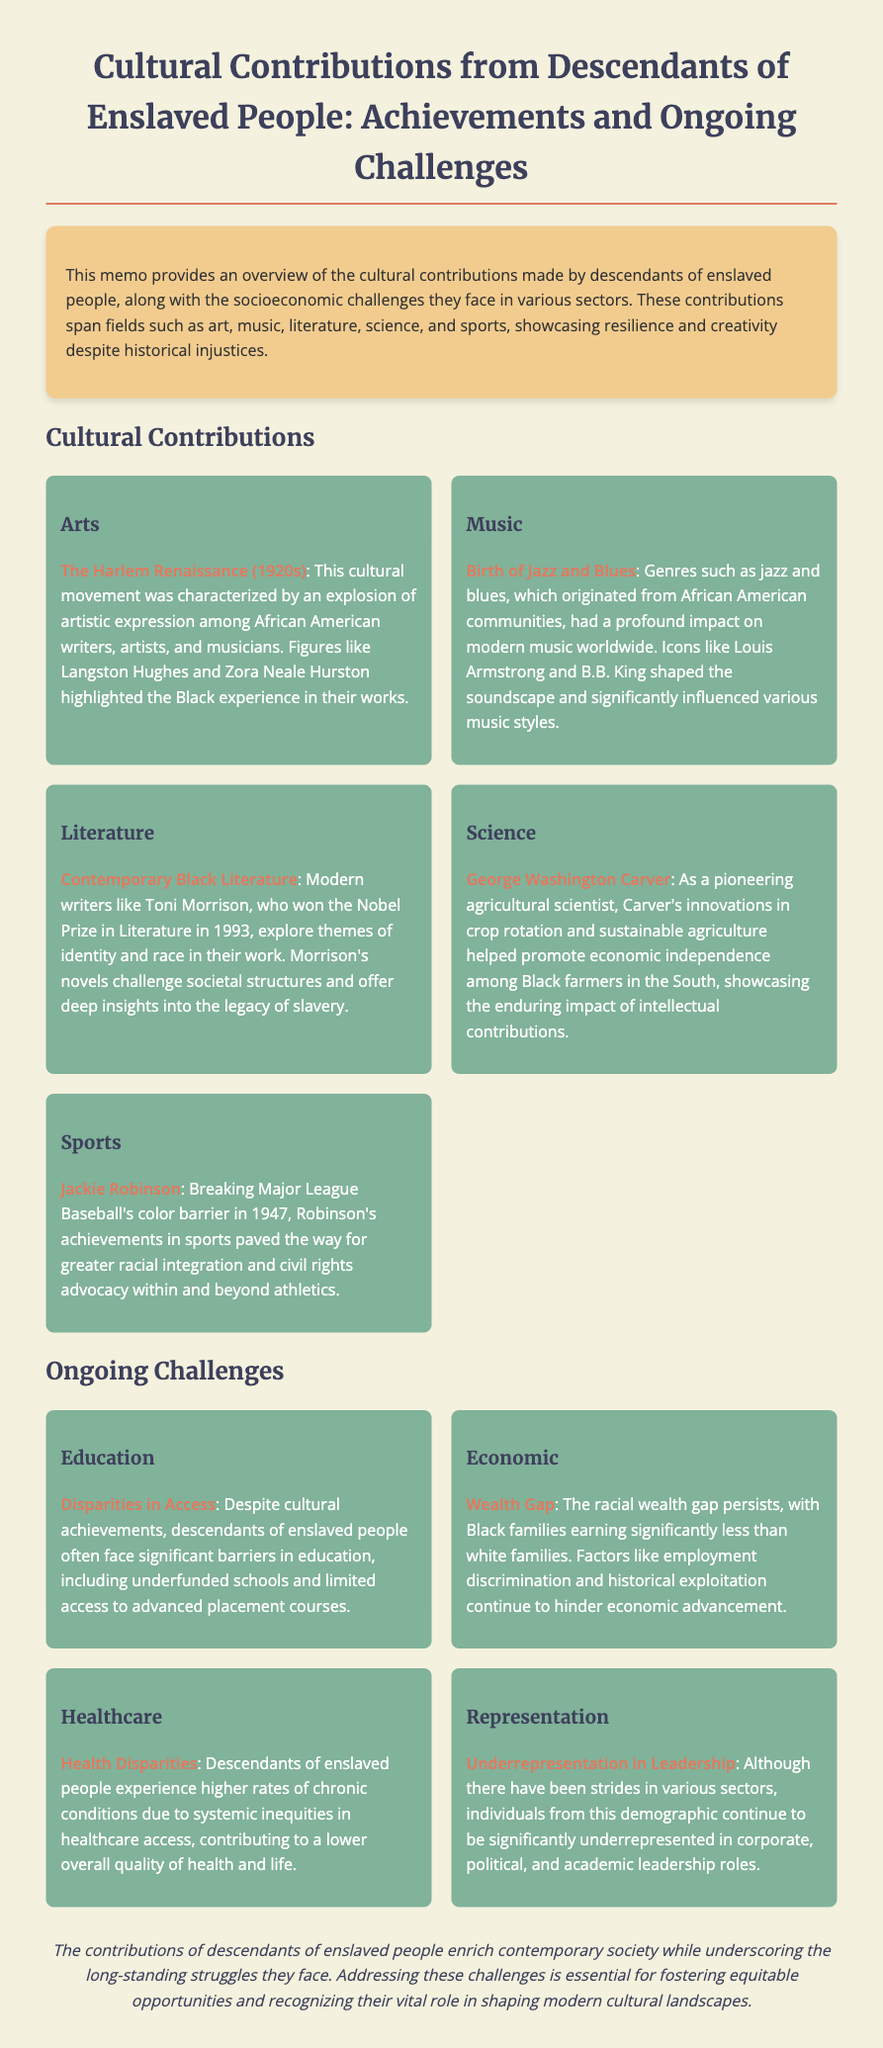what cultural movement is highlighted in the document? The document mentions the Harlem Renaissance as a significant cultural movement among African American writers, artists, and musicians.
Answer: Harlem Renaissance who was a pioneering agricultural scientist mentioned in the memo? The memo highlights George Washington Carver as a pioneering agricultural scientist.
Answer: George Washington Carver what genre of music originated from African American communities? The document states that jazz and blues are genres that originated from African American communities.
Answer: Jazz and blues what major barrier do descendants of enslaved people face in education? The document notes that descendants of enslaved people face disparities in access to education, including underfunded schools.
Answer: Disparities in Access which athlete broke Major League Baseball's color barrier in 1947? The memo states that Jackie Robinson broke Major League Baseball's color barrier in 1947.
Answer: Jackie Robinson what health issue do descendants of enslaved people experience higher rates of? The document mentions that descendants of enslaved people have higher rates of chronic conditions.
Answer: Chronic conditions what is the overall quality of health mentioned for descendants of enslaved people? The document indicates that systemic inequities in healthcare access contribute to a lower overall quality of health and life.
Answer: Lower quality of health what contribution did contemporary Black literature focus on? The memo highlights that contemporary Black literature explores themes of identity and race.
Answer: Identity and race what is a significant ongoing economic challenge for descendants of enslaved people? The memo points out the racial wealth gap as a significant ongoing economic challenge.
Answer: Wealth Gap 